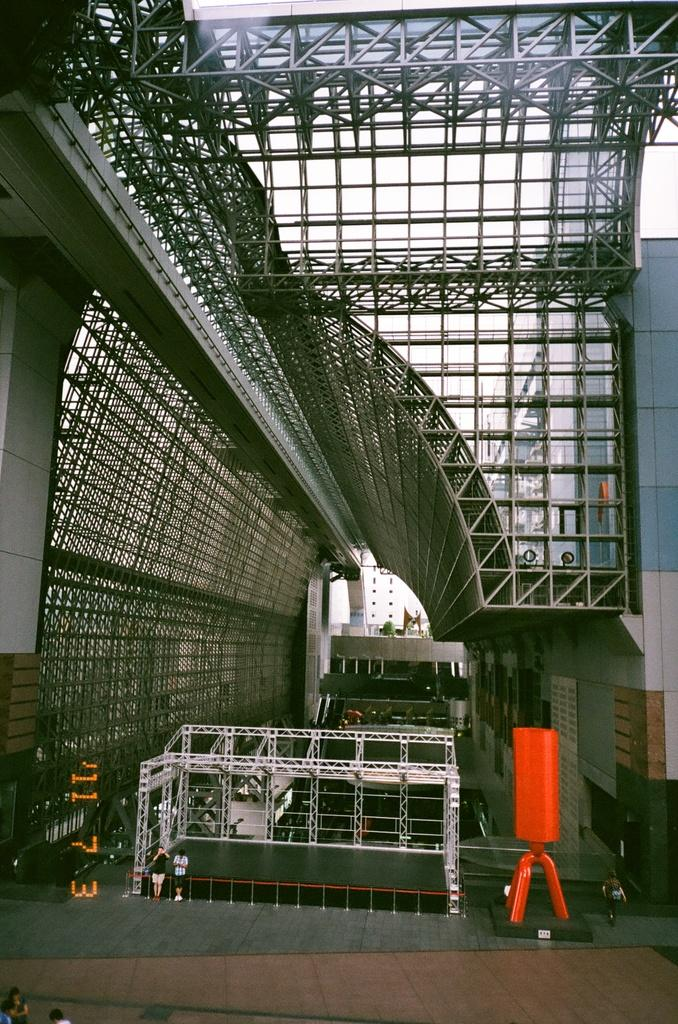What is the primary location of the people in the image? The people are on the ground in the image. What type of material is used for the rods visible in the image? The rods are made of metal. What structure can be seen in the image? There is a wall in the image. Can you describe the objects present in the image? Unfortunately, the provided facts do not specify the nature of the objects present in the image. How many nuts are being turned by the people in the image? There are no nuts or turning actions depicted in the image. 